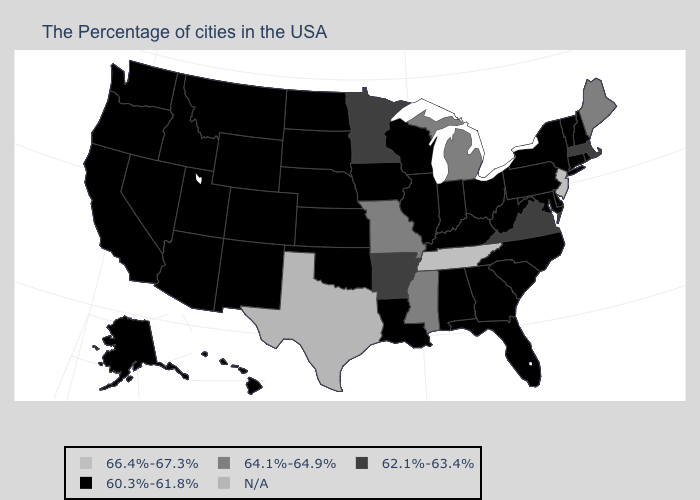Does the first symbol in the legend represent the smallest category?
Keep it brief. No. Is the legend a continuous bar?
Quick response, please. No. What is the lowest value in states that border Colorado?
Keep it brief. 60.3%-61.8%. Name the states that have a value in the range 64.1%-64.9%?
Write a very short answer. Maine, Michigan, Mississippi, Missouri. Does South Dakota have the highest value in the MidWest?
Give a very brief answer. No. Name the states that have a value in the range N/A?
Quick response, please. Texas. What is the value of Oklahoma?
Concise answer only. 60.3%-61.8%. What is the value of Georgia?
Be succinct. 60.3%-61.8%. What is the value of Hawaii?
Answer briefly. 60.3%-61.8%. Name the states that have a value in the range 60.3%-61.8%?
Answer briefly. Rhode Island, New Hampshire, Vermont, Connecticut, New York, Delaware, Maryland, Pennsylvania, North Carolina, South Carolina, West Virginia, Ohio, Florida, Georgia, Kentucky, Indiana, Alabama, Wisconsin, Illinois, Louisiana, Iowa, Kansas, Nebraska, Oklahoma, South Dakota, North Dakota, Wyoming, Colorado, New Mexico, Utah, Montana, Arizona, Idaho, Nevada, California, Washington, Oregon, Alaska, Hawaii. What is the highest value in states that border Pennsylvania?
Short answer required. 66.4%-67.3%. Among the states that border South Dakota , does Minnesota have the highest value?
Short answer required. Yes. 